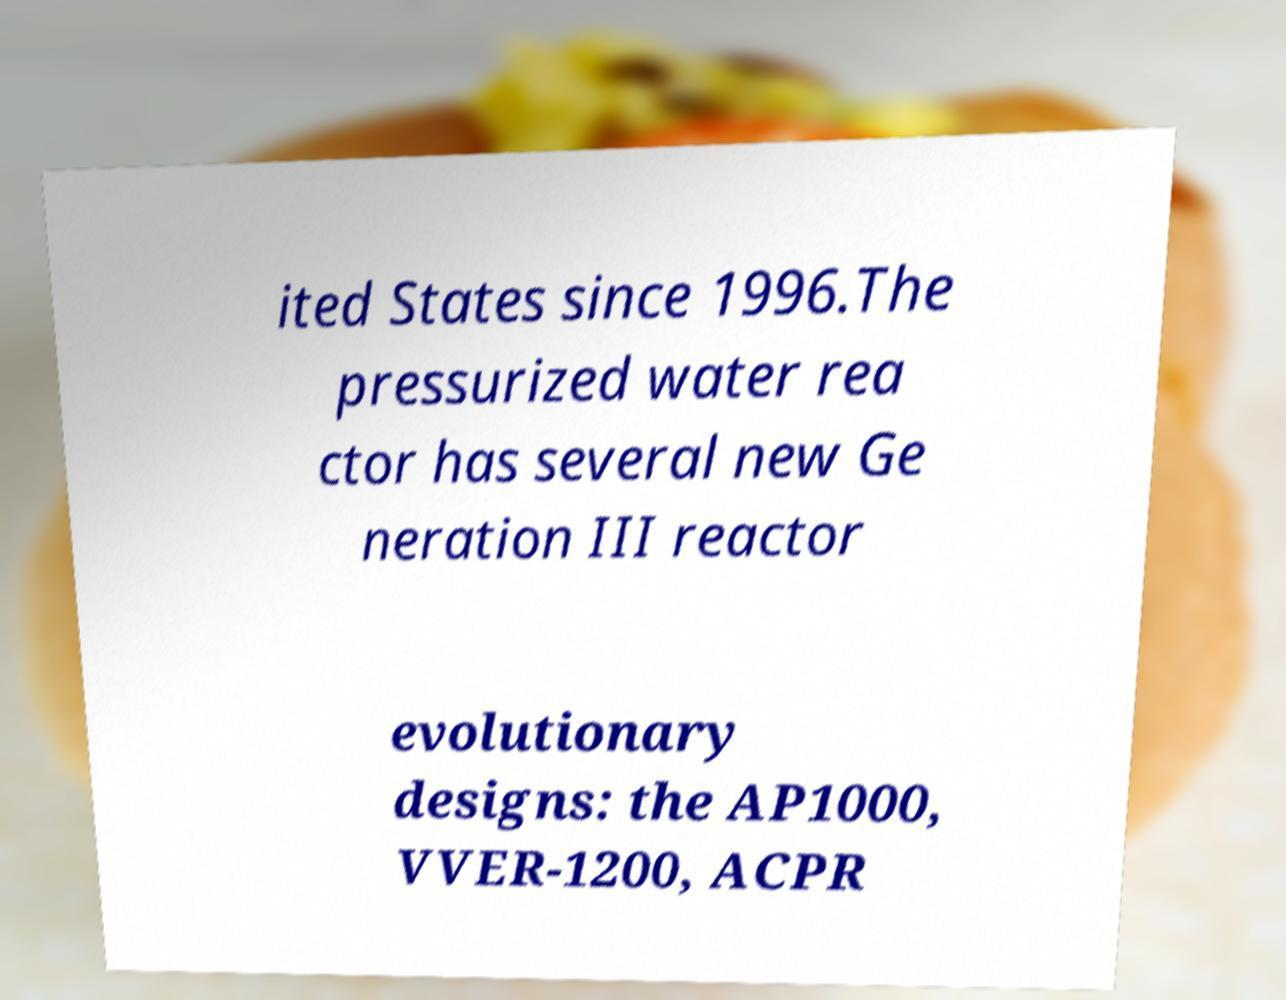Can you read and provide the text displayed in the image?This photo seems to have some interesting text. Can you extract and type it out for me? ited States since 1996.The pressurized water rea ctor has several new Ge neration III reactor evolutionary designs: the AP1000, VVER-1200, ACPR 